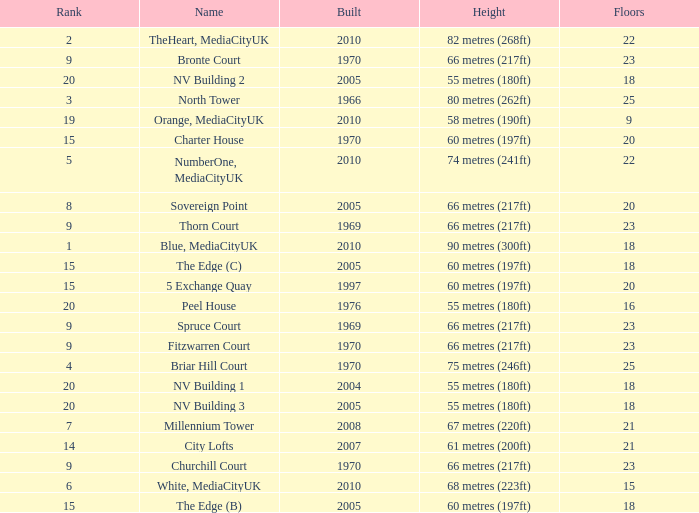What is Height, when Rank is less than 20, when Floors is greater than 9, when Built is 2005, and when Name is The Edge (C)? 60 metres (197ft). 